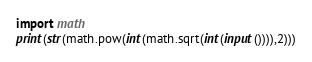Convert code to text. <code><loc_0><loc_0><loc_500><loc_500><_Python_>import math
print(str(math.pow(int(math.sqrt(int(input()))),2)))</code> 